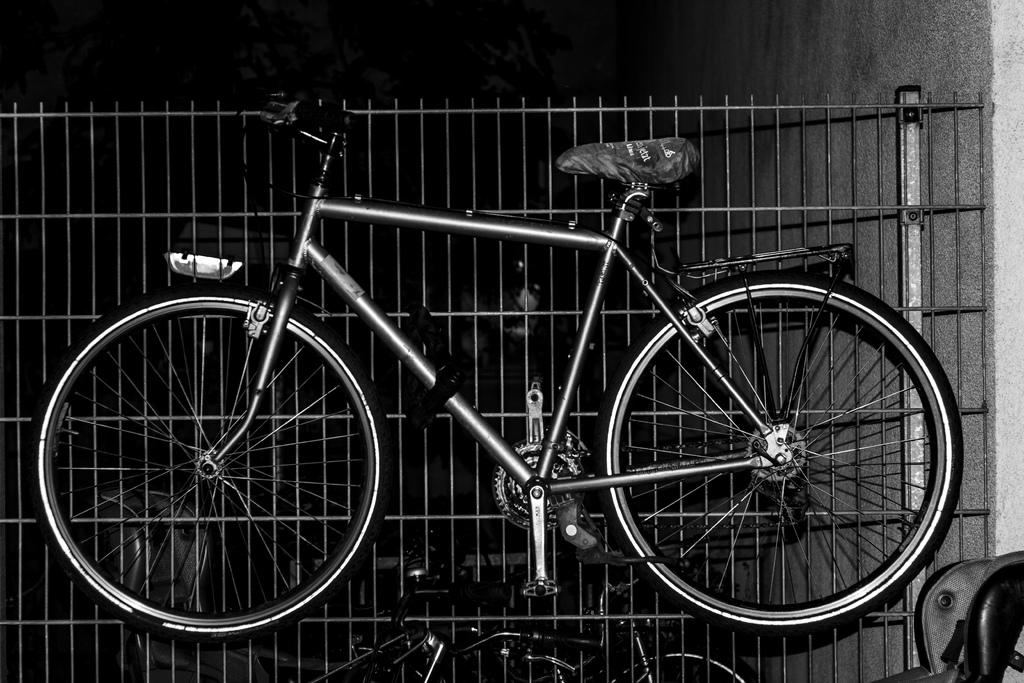What is the main subject in the middle of the image? There is a bicycle in the middle of the image. What can be seen in the background of the image? There is a metal fence and additional bicycles in the background of the image. What is located on the right side of the image? There is a wall on the right side of the image. What type of home is depicted in the image? There is no home depicted in the image; it primarily features a bicycle, a metal fence, and a wall. 